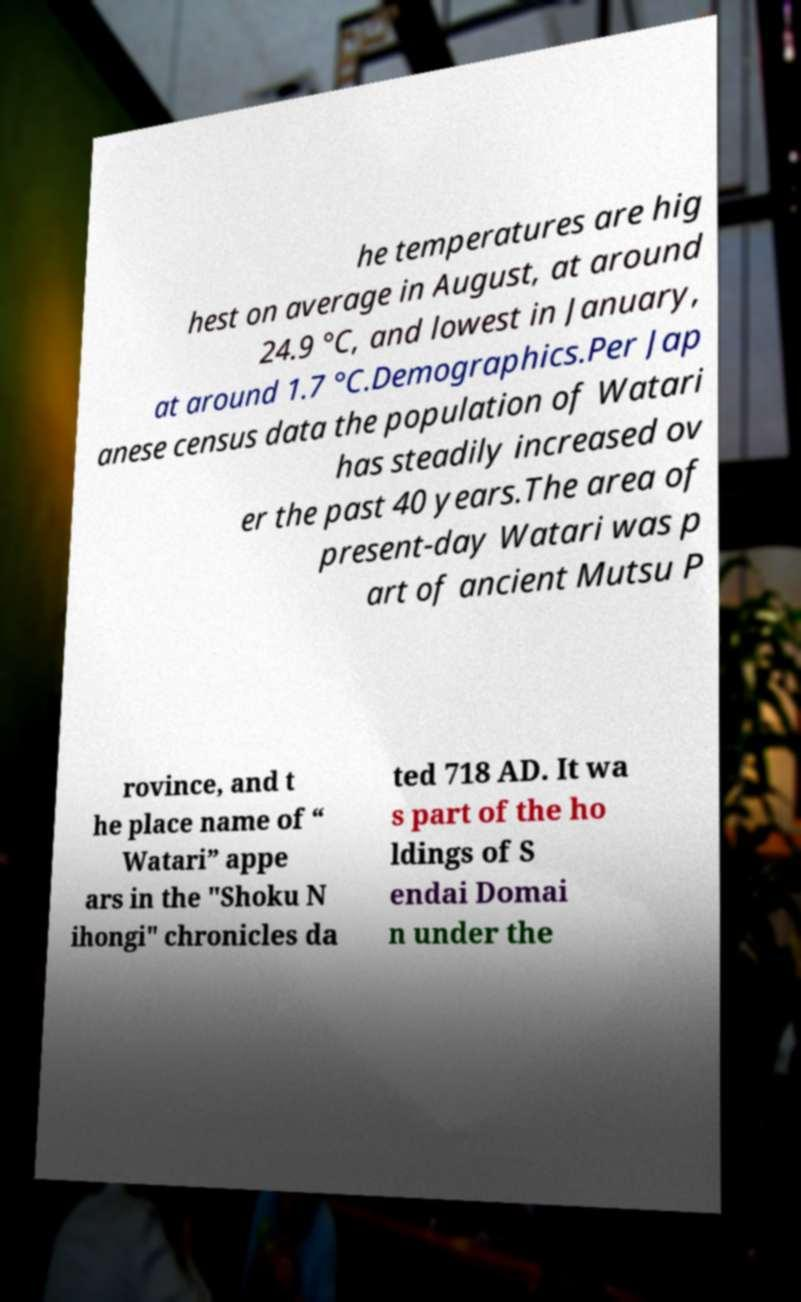Please identify and transcribe the text found in this image. he temperatures are hig hest on average in August, at around 24.9 °C, and lowest in January, at around 1.7 °C.Demographics.Per Jap anese census data the population of Watari has steadily increased ov er the past 40 years.The area of present-day Watari was p art of ancient Mutsu P rovince, and t he place name of “ Watari” appe ars in the "Shoku N ihongi" chronicles da ted 718 AD. It wa s part of the ho ldings of S endai Domai n under the 